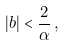Convert formula to latex. <formula><loc_0><loc_0><loc_500><loc_500>| b | < \frac { 2 } { \alpha } \, ,</formula> 